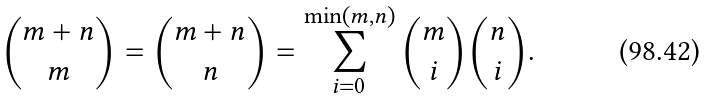<formula> <loc_0><loc_0><loc_500><loc_500>\binom { m + n } { m } = \binom { m + n } { n } = \sum _ { i = 0 } ^ { \min ( m , n ) } \binom { m } { i } \binom { n } { i } .</formula> 